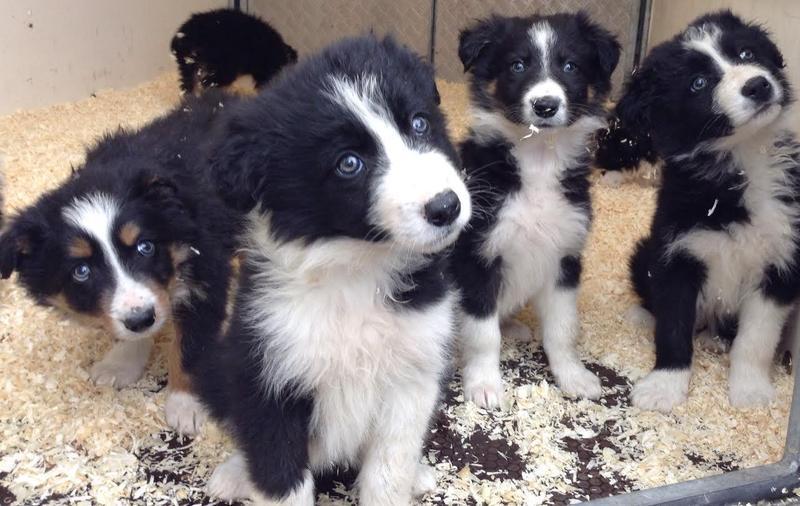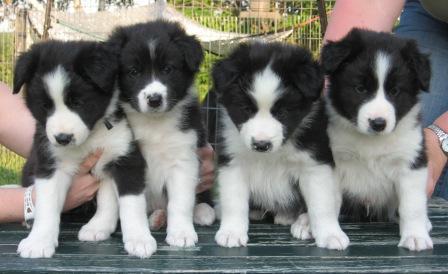The first image is the image on the left, the second image is the image on the right. Given the left and right images, does the statement "There is at least one human petting puppies in one of the images." hold true? Answer yes or no. Yes. 